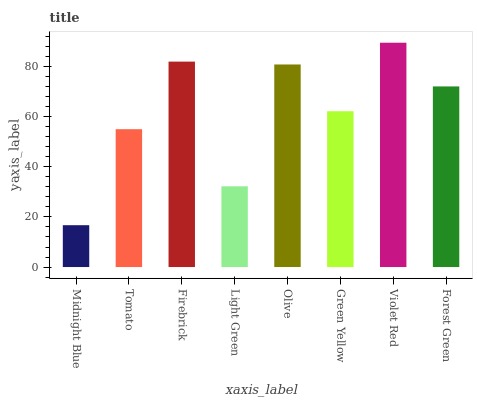Is Midnight Blue the minimum?
Answer yes or no. Yes. Is Violet Red the maximum?
Answer yes or no. Yes. Is Tomato the minimum?
Answer yes or no. No. Is Tomato the maximum?
Answer yes or no. No. Is Tomato greater than Midnight Blue?
Answer yes or no. Yes. Is Midnight Blue less than Tomato?
Answer yes or no. Yes. Is Midnight Blue greater than Tomato?
Answer yes or no. No. Is Tomato less than Midnight Blue?
Answer yes or no. No. Is Forest Green the high median?
Answer yes or no. Yes. Is Green Yellow the low median?
Answer yes or no. Yes. Is Olive the high median?
Answer yes or no. No. Is Tomato the low median?
Answer yes or no. No. 